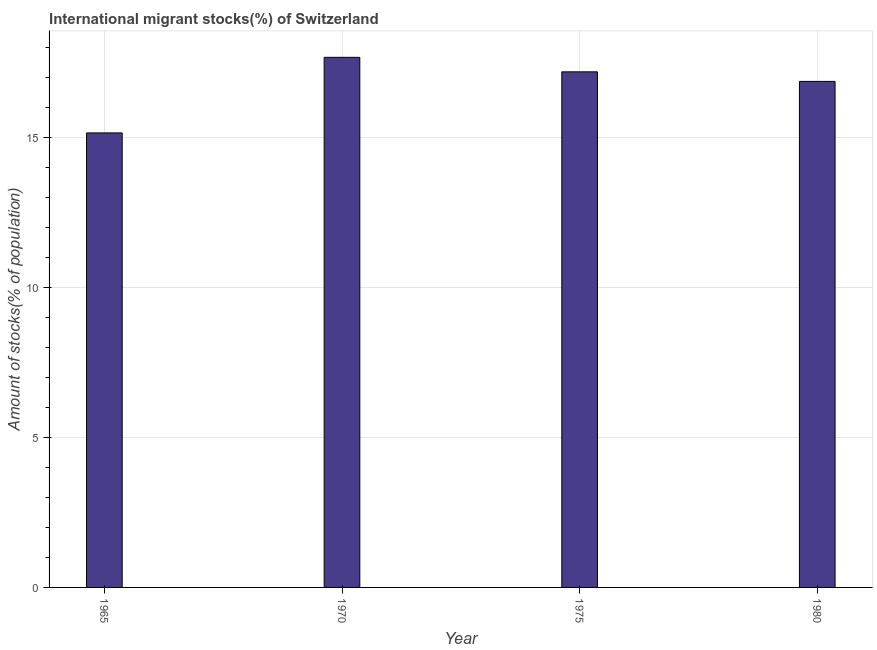Does the graph contain any zero values?
Ensure brevity in your answer.  No. What is the title of the graph?
Ensure brevity in your answer.  International migrant stocks(%) of Switzerland. What is the label or title of the X-axis?
Make the answer very short. Year. What is the label or title of the Y-axis?
Make the answer very short. Amount of stocks(% of population). What is the number of international migrant stocks in 1970?
Keep it short and to the point. 17.67. Across all years, what is the maximum number of international migrant stocks?
Offer a terse response. 17.67. Across all years, what is the minimum number of international migrant stocks?
Give a very brief answer. 15.15. In which year was the number of international migrant stocks maximum?
Make the answer very short. 1970. In which year was the number of international migrant stocks minimum?
Your answer should be compact. 1965. What is the sum of the number of international migrant stocks?
Offer a terse response. 66.86. What is the difference between the number of international migrant stocks in 1975 and 1980?
Your answer should be very brief. 0.32. What is the average number of international migrant stocks per year?
Give a very brief answer. 16.72. What is the median number of international migrant stocks?
Provide a succinct answer. 17.02. What is the ratio of the number of international migrant stocks in 1965 to that in 1970?
Keep it short and to the point. 0.86. Is the number of international migrant stocks in 1965 less than that in 1975?
Your answer should be compact. Yes. Is the difference between the number of international migrant stocks in 1970 and 1980 greater than the difference between any two years?
Provide a short and direct response. No. What is the difference between the highest and the second highest number of international migrant stocks?
Make the answer very short. 0.48. Is the sum of the number of international migrant stocks in 1965 and 1980 greater than the maximum number of international migrant stocks across all years?
Make the answer very short. Yes. What is the difference between the highest and the lowest number of international migrant stocks?
Ensure brevity in your answer.  2.52. Are all the bars in the graph horizontal?
Your answer should be compact. No. What is the difference between two consecutive major ticks on the Y-axis?
Ensure brevity in your answer.  5. What is the Amount of stocks(% of population) in 1965?
Keep it short and to the point. 15.15. What is the Amount of stocks(% of population) in 1970?
Give a very brief answer. 17.67. What is the Amount of stocks(% of population) of 1975?
Your answer should be compact. 17.18. What is the Amount of stocks(% of population) of 1980?
Provide a succinct answer. 16.87. What is the difference between the Amount of stocks(% of population) in 1965 and 1970?
Offer a terse response. -2.52. What is the difference between the Amount of stocks(% of population) in 1965 and 1975?
Ensure brevity in your answer.  -2.04. What is the difference between the Amount of stocks(% of population) in 1965 and 1980?
Keep it short and to the point. -1.72. What is the difference between the Amount of stocks(% of population) in 1970 and 1975?
Your response must be concise. 0.48. What is the difference between the Amount of stocks(% of population) in 1970 and 1980?
Your answer should be compact. 0.8. What is the difference between the Amount of stocks(% of population) in 1975 and 1980?
Provide a succinct answer. 0.32. What is the ratio of the Amount of stocks(% of population) in 1965 to that in 1970?
Provide a succinct answer. 0.86. What is the ratio of the Amount of stocks(% of population) in 1965 to that in 1975?
Give a very brief answer. 0.88. What is the ratio of the Amount of stocks(% of population) in 1965 to that in 1980?
Your response must be concise. 0.9. What is the ratio of the Amount of stocks(% of population) in 1970 to that in 1975?
Ensure brevity in your answer.  1.03. What is the ratio of the Amount of stocks(% of population) in 1970 to that in 1980?
Offer a very short reply. 1.05. 